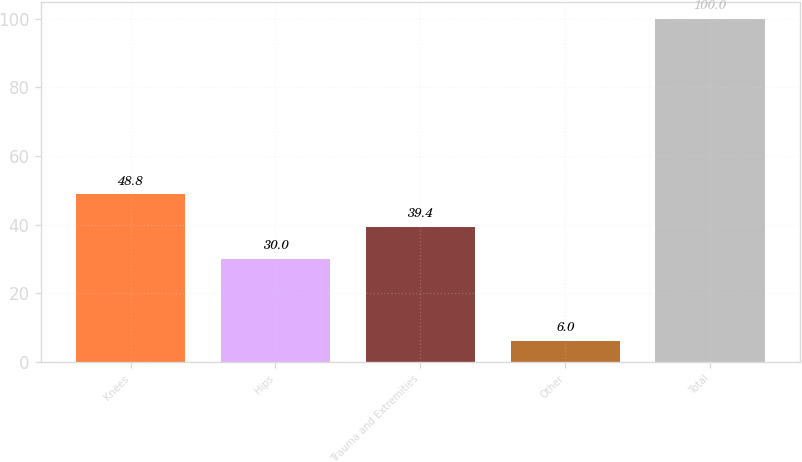Convert chart. <chart><loc_0><loc_0><loc_500><loc_500><bar_chart><fcel>Knees<fcel>Hips<fcel>Trauma and Extremities<fcel>Other<fcel>Total<nl><fcel>48.8<fcel>30<fcel>39.4<fcel>6<fcel>100<nl></chart> 